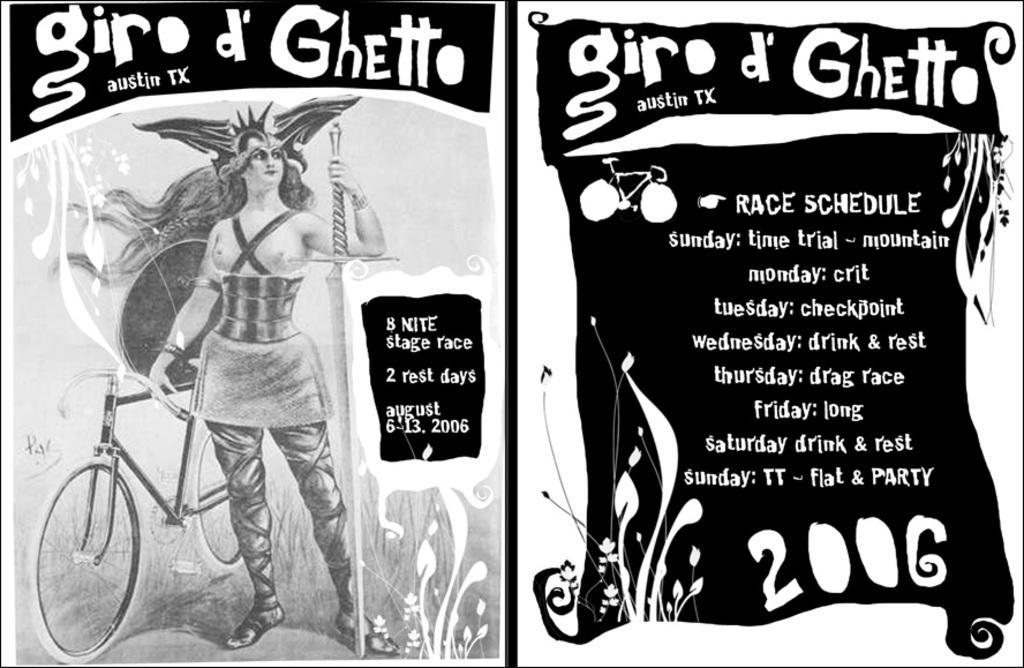What can be seen hanging on the walls in the image? There are posters in the image. Where is the person located in the image? The person is standing on the left side of the image. What is beside the person in the image? There is a cycle beside the person. What is written or displayed on the right side of the image? There is text on the right side of the image. How many spiders are crawling on the person's underwear in the image? There are no spiders or underwear present in the image. What type of air is visible in the image? There is no specific type of air visible in the image; the focus is on the posters, person, cycle, and text. 